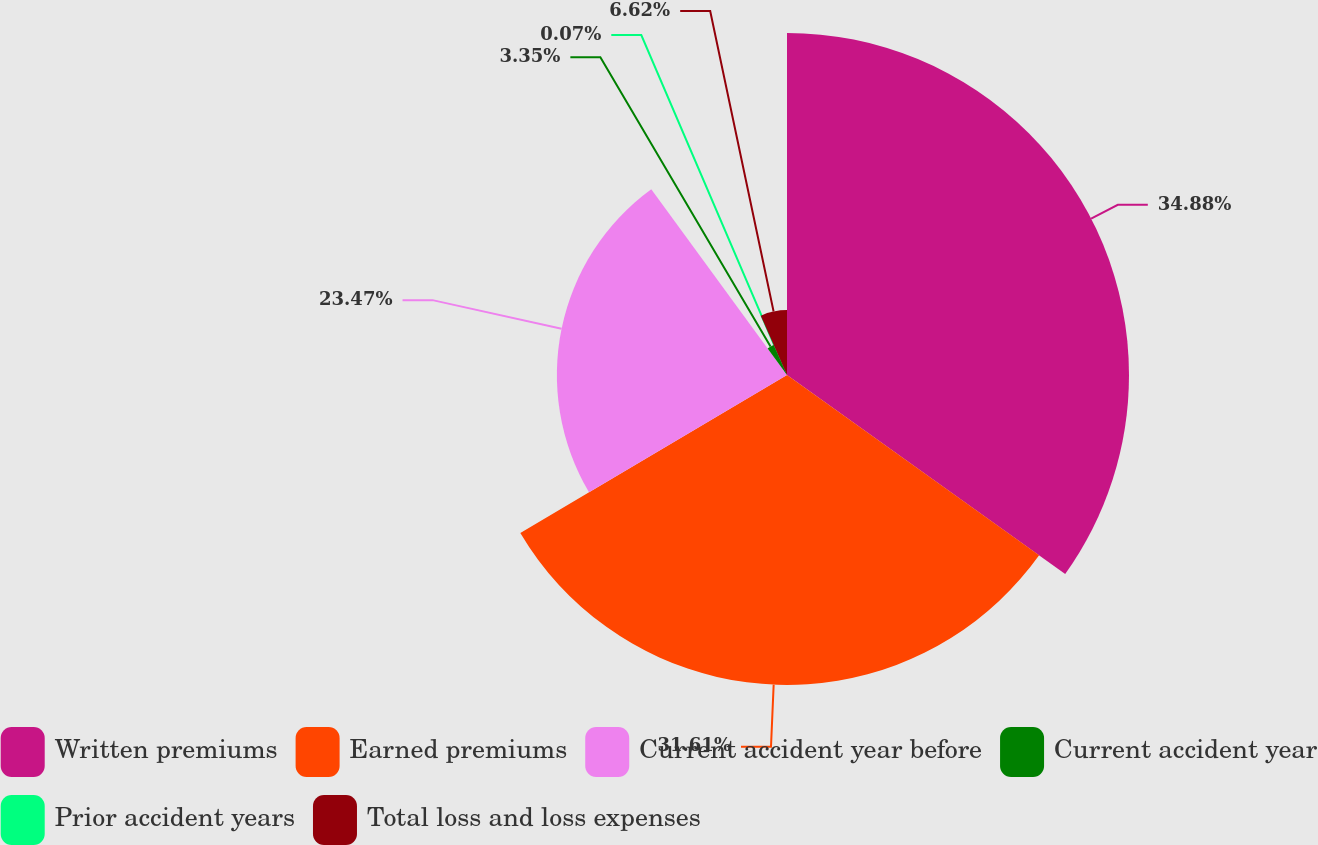Convert chart. <chart><loc_0><loc_0><loc_500><loc_500><pie_chart><fcel>Written premiums<fcel>Earned premiums<fcel>Current accident year before<fcel>Current accident year<fcel>Prior accident years<fcel>Total loss and loss expenses<nl><fcel>34.88%<fcel>31.61%<fcel>23.47%<fcel>3.35%<fcel>0.07%<fcel>6.62%<nl></chart> 